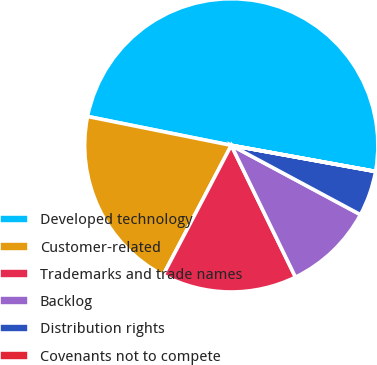Convert chart. <chart><loc_0><loc_0><loc_500><loc_500><pie_chart><fcel>Developed technology<fcel>Customer-related<fcel>Trademarks and trade names<fcel>Backlog<fcel>Distribution rights<fcel>Covenants not to compete<nl><fcel>49.69%<fcel>20.46%<fcel>14.91%<fcel>9.95%<fcel>4.98%<fcel>0.01%<nl></chart> 